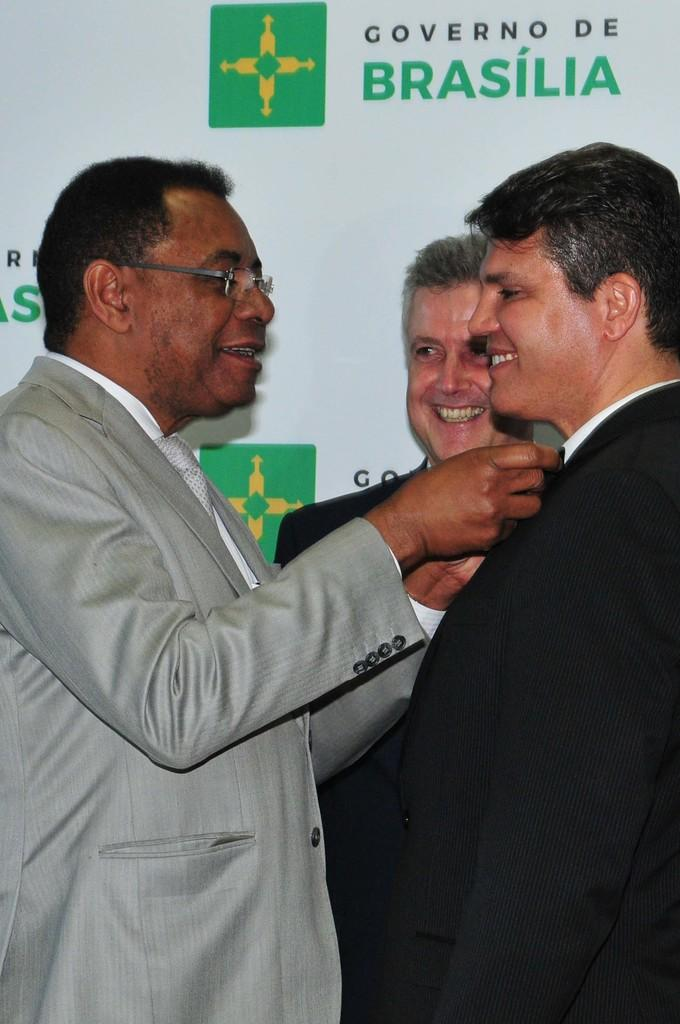What are the people in the image doing? The people in the image are standing in the center and smiling. What can be seen in the background of the image? There is a banner in the background of the image. Where is the basin located in the image? There is no basin present in the image. What type of surprise is being revealed in the image? There is no surprise being revealed in the image; it simply shows people standing and smiling. 